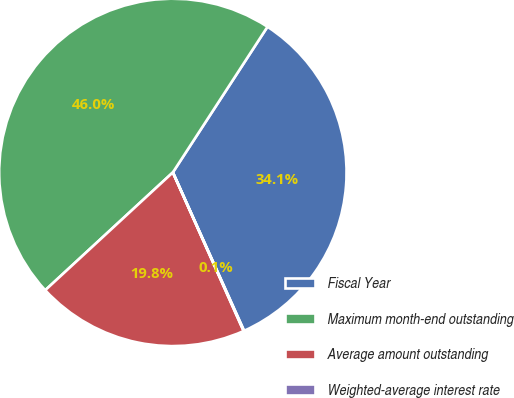<chart> <loc_0><loc_0><loc_500><loc_500><pie_chart><fcel>Fiscal Year<fcel>Maximum month-end outstanding<fcel>Average amount outstanding<fcel>Weighted-average interest rate<nl><fcel>34.1%<fcel>46.03%<fcel>19.81%<fcel>0.05%<nl></chart> 